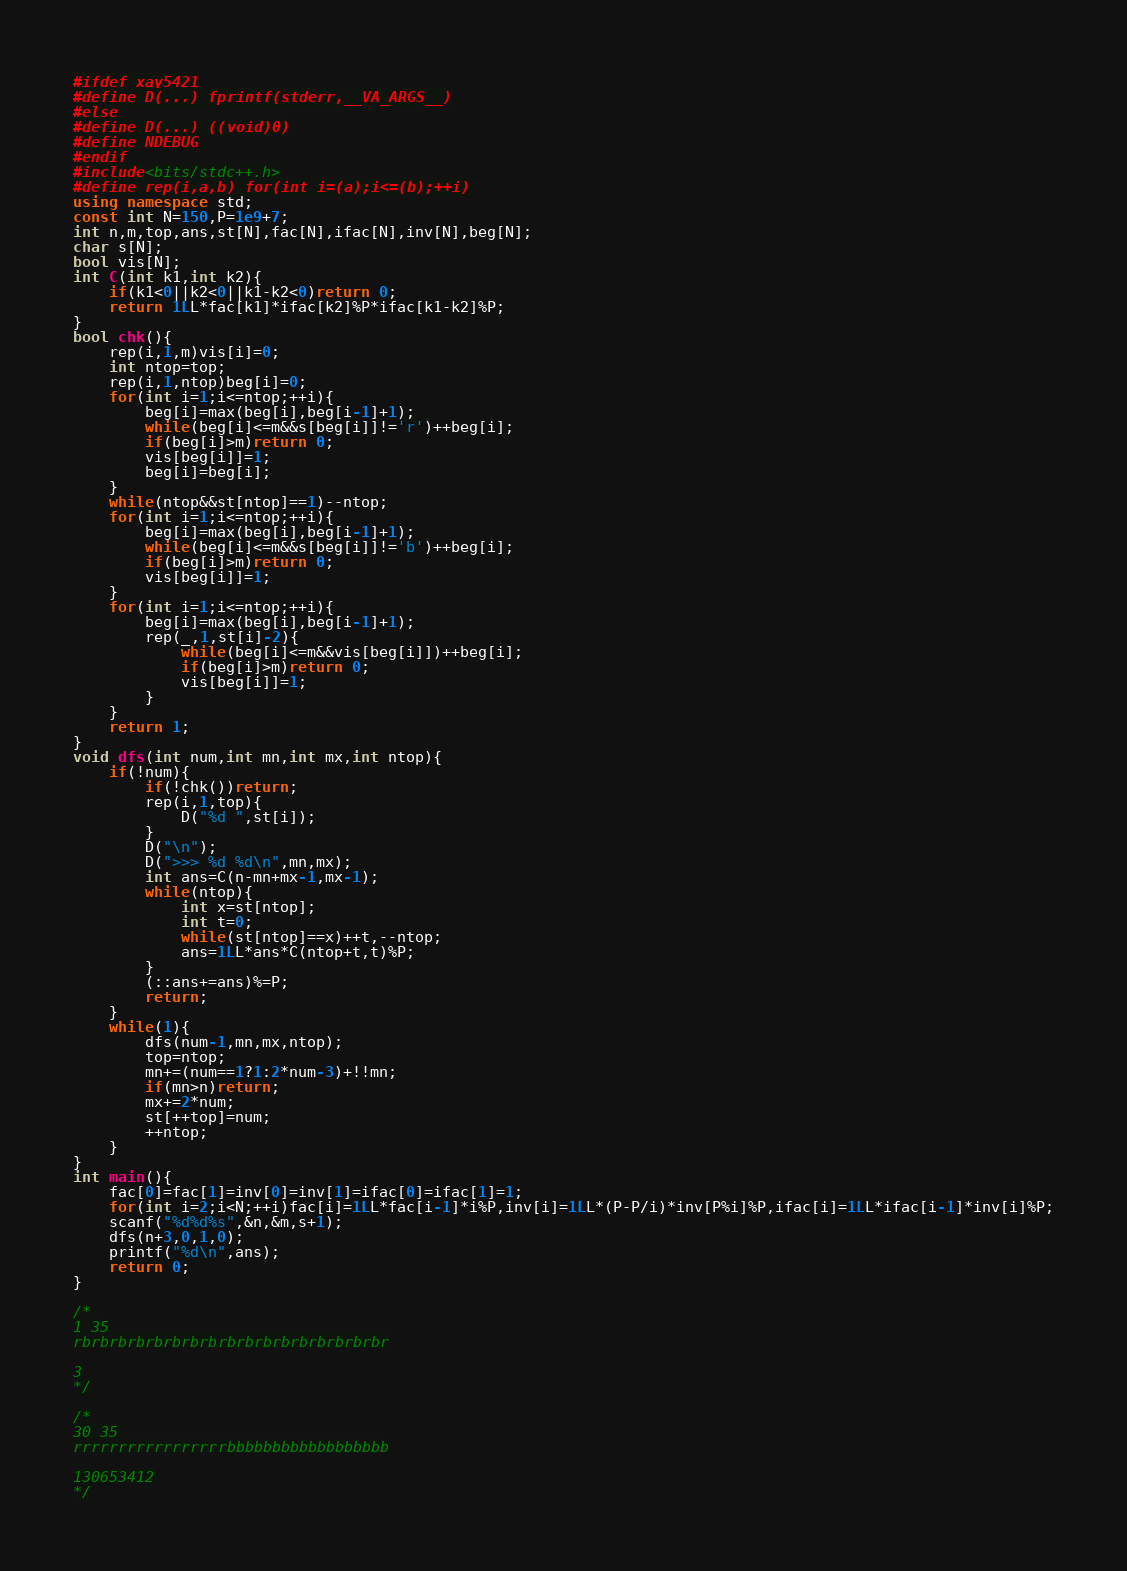<code> <loc_0><loc_0><loc_500><loc_500><_C++_>#ifdef xay5421
#define D(...) fprintf(stderr,__VA_ARGS__)
#else
#define D(...) ((void)0)
#define NDEBUG
#endif
#include<bits/stdc++.h>
#define rep(i,a,b) for(int i=(a);i<=(b);++i)
using namespace std;
const int N=150,P=1e9+7;
int n,m,top,ans,st[N],fac[N],ifac[N],inv[N],beg[N];
char s[N];
bool vis[N];
int C(int k1,int k2){
	if(k1<0||k2<0||k1-k2<0)return 0;
	return 1LL*fac[k1]*ifac[k2]%P*ifac[k1-k2]%P;
}
bool chk(){
	rep(i,1,m)vis[i]=0;
	int ntop=top;
	rep(i,1,ntop)beg[i]=0;
	for(int i=1;i<=ntop;++i){
		beg[i]=max(beg[i],beg[i-1]+1);
		while(beg[i]<=m&&s[beg[i]]!='r')++beg[i];
		if(beg[i]>m)return 0;
		vis[beg[i]]=1;
		beg[i]=beg[i];
	}
	while(ntop&&st[ntop]==1)--ntop;
	for(int i=1;i<=ntop;++i){
		beg[i]=max(beg[i],beg[i-1]+1);
		while(beg[i]<=m&&s[beg[i]]!='b')++beg[i];
		if(beg[i]>m)return 0;
		vis[beg[i]]=1;
	}
	for(int i=1;i<=ntop;++i){
		beg[i]=max(beg[i],beg[i-1]+1);
		rep(_,1,st[i]-2){
			while(beg[i]<=m&&vis[beg[i]])++beg[i];
			if(beg[i]>m)return 0;
			vis[beg[i]]=1;
		}
	}
	return 1;
}
void dfs(int num,int mn,int mx,int ntop){
	if(!num){
		if(!chk())return;
		rep(i,1,top){
			D("%d ",st[i]);
		}
		D("\n");
		D(">>> %d %d\n",mn,mx);
		int ans=C(n-mn+mx-1,mx-1);
		while(ntop){
			int x=st[ntop];
			int t=0;
			while(st[ntop]==x)++t,--ntop;
			ans=1LL*ans*C(ntop+t,t)%P;
		}
		(::ans+=ans)%=P;
		return;
	}
	while(1){
		dfs(num-1,mn,mx,ntop);
		top=ntop;
		mn+=(num==1?1:2*num-3)+!!mn;
		if(mn>n)return;
		mx+=2*num;
		st[++top]=num;
		++ntop;
	}
}
int main(){
	fac[0]=fac[1]=inv[0]=inv[1]=ifac[0]=ifac[1]=1;
	for(int i=2;i<N;++i)fac[i]=1LL*fac[i-1]*i%P,inv[i]=1LL*(P-P/i)*inv[P%i]%P,ifac[i]=1LL*ifac[i-1]*inv[i]%P;
	scanf("%d%d%s",&n,&m,s+1);
	dfs(n+3,0,1,0);
	printf("%d\n",ans);
	return 0;
}

/*
1 35
rbrbrbrbrbrbrbrbrbrbrbrbrbrbrbrbrbr

3
*/

/*
30 35
rrrrrrrrrrrrrrrrrbbbbbbbbbbbbbbbbbb

130653412
*/</code> 